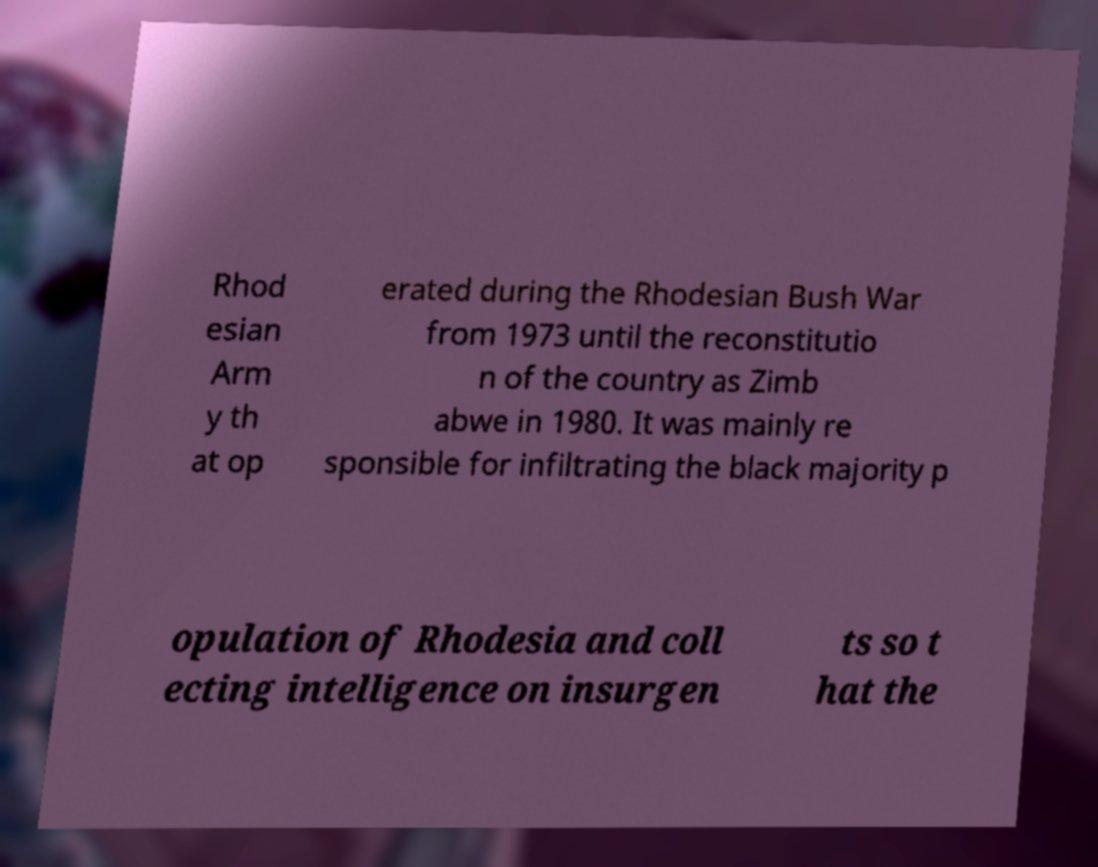Could you extract and type out the text from this image? Rhod esian Arm y th at op erated during the Rhodesian Bush War from 1973 until the reconstitutio n of the country as Zimb abwe in 1980. It was mainly re sponsible for infiltrating the black majority p opulation of Rhodesia and coll ecting intelligence on insurgen ts so t hat the 